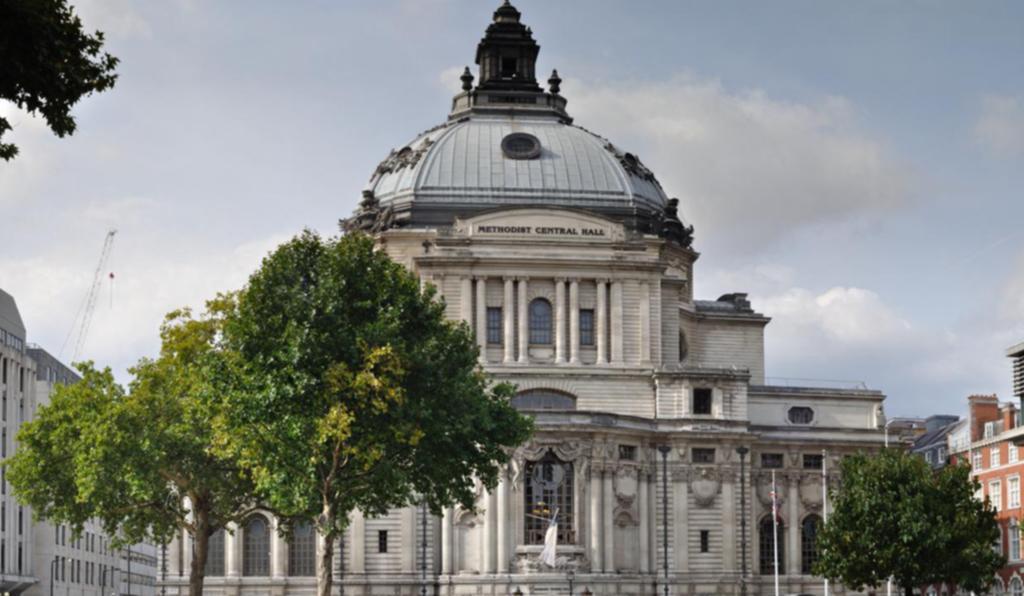Can you describe this image briefly? In the image there is a palace in the back with trees in front of it on either side and above its sky with clouds. 